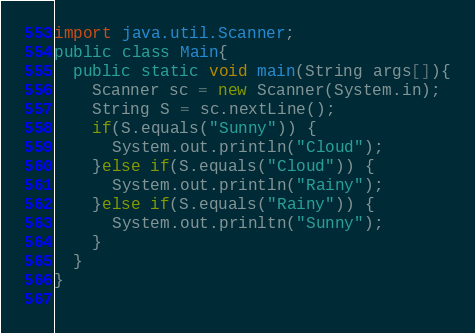Convert code to text. <code><loc_0><loc_0><loc_500><loc_500><_Java_>import java.util.Scanner;
public class Main{
  public static void main(String args[]){
    Scanner sc = new Scanner(System.in);
    String S = sc.nextLine();
    if(S.equals("Sunny")) {
      System.out.println("Cloud");
    }else if(S.equals("Cloud")) {
      System.out.println("Rainy");
    }else if(S.equals("Rainy")) {
      System.out.prinltn("Sunny");
    }
  }
}
  </code> 